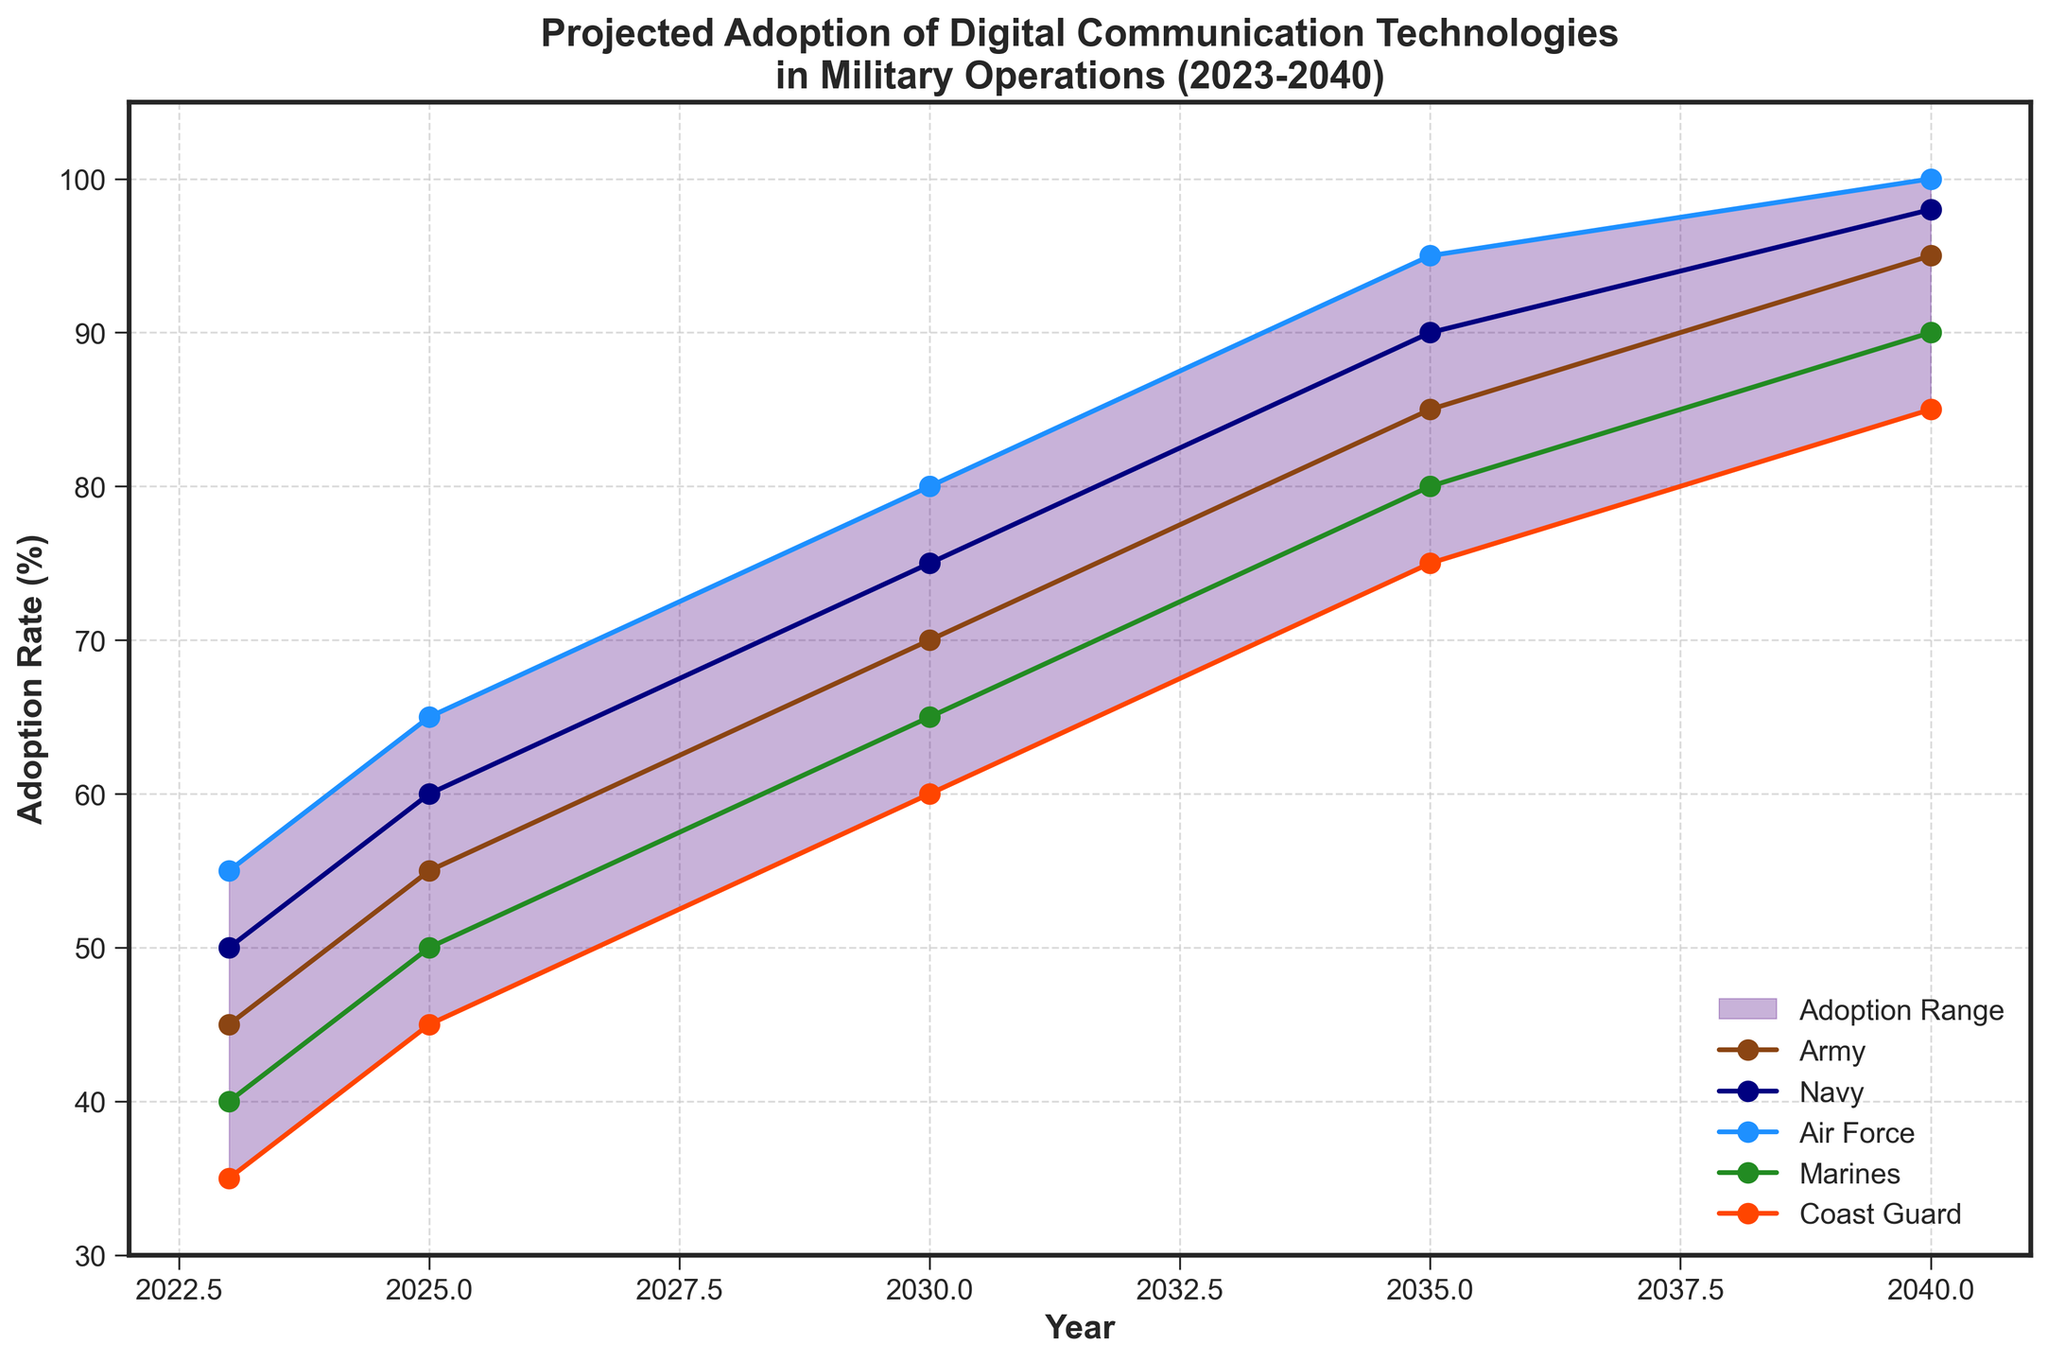What's the title of the figure? The title of the figure is located at the top and provides an overview of what the plot represents. In this case, the title text reads: "Projected Adoption of Digital Communication Technologies in Military Operations (2023-2040)".
Answer: Projected Adoption of Digital Communication Technologies in Military Operations (2023-2040) What adoption rate range is shaded on the fan chart? The shaded area on the fan chart represents the adoption range, which is defined between the low and high projection values given in the data. The visual difference between these two lines creates the shaded region.
Answer: 35% to 100% Which service branch is projected to have the highest adoption rate in 2040? To determine this, look at the endpoints of each service branch's line in 2040. The highest point indicates the highest adoption rate. The Air Force line reaches the highest point at 100%.
Answer: Air Force In what year do the Marines surpass a 50% adoption rate? Track the Marines' adoption rate line and see where it first crosses the 50% mark on the Y-axis. This occurs between 2023 and 2025, specifically in 2025.
Answer: 2025 By how much does the Army's adoption rate increase from 2023 to 2030? Calculate the difference between the Army's adoption rate in 2030 and 2023. The values are 70% in 2030 and 45% in 2023, so the increase is 70 - 45.
Answer: 25% Which service branch has the lowest adoption rate in 2023? To find this, look at the starting points of each line in the year 2023. The Coast Guard has the lowest starting point at 35%.
Answer: Coast Guard Compare the adoption rates of the Navy and Air Force in 2035. Which one is higher and by how much? Check the values for each branch in 2035. The Navy has an adoption rate of 90% and the Air Force has 95%. The difference is 95 - 90.
Answer: Air Force by 5% What is the average adoption rate of the Navy over the given years? To find the average, sum up the Navy's adoption rates for all provided years and divide by the number of years (5). The values are 50, 60, 75, 90, and 98. Thus, (50 + 60 + 75 + 90 + 98) / 5.
Answer: 74.6% Considering the shaded fan chart area, in which year does the upper limit first reach 100%? Look at the high projection line within the shaded area to see where it first reaches 100%. This occurs in 2040.
Answer: 2040 By which year does the Coast Guard achieve an adoption rate of at least 50%? Follow the Coast Guard's adoption rate line to see when it first reaches or surpasses a 50% adoption rate. This occurs in 2025.
Answer: 2025 